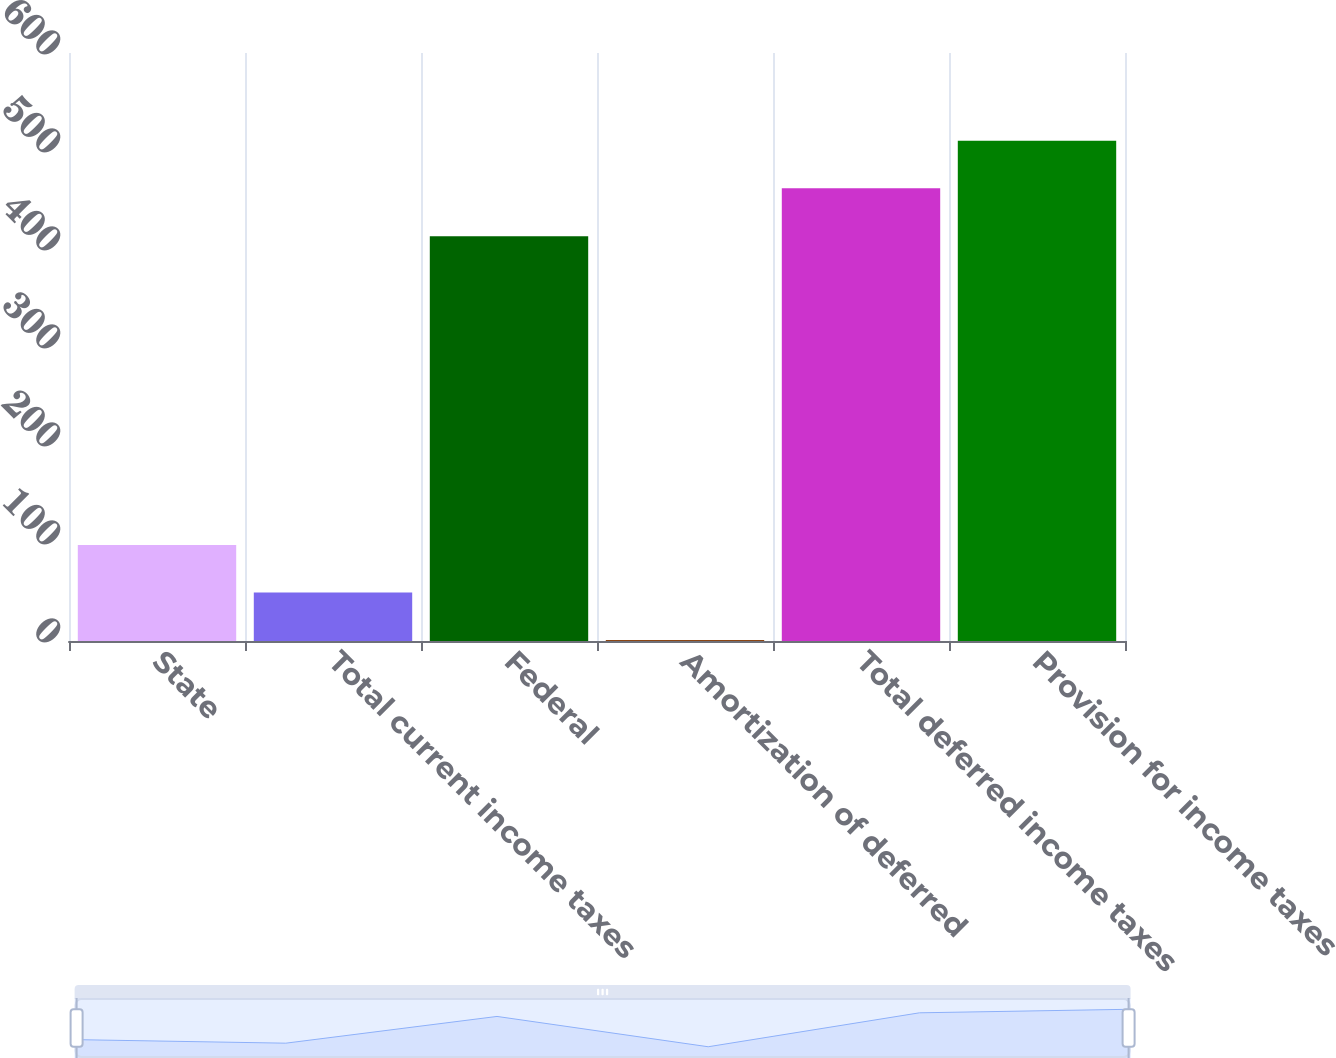<chart> <loc_0><loc_0><loc_500><loc_500><bar_chart><fcel>State<fcel>Total current income taxes<fcel>Federal<fcel>Amortization of deferred<fcel>Total deferred income taxes<fcel>Provision for income taxes<nl><fcel>98<fcel>49.5<fcel>413<fcel>1<fcel>462<fcel>510.5<nl></chart> 